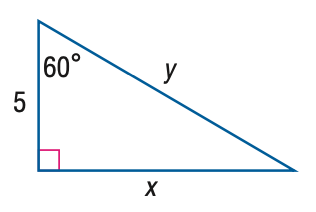Answer the mathemtical geometry problem and directly provide the correct option letter.
Question: Find y.
Choices: A: 5 B: 5 \sqrt { 2 } C: 5 \sqrt { 3 } D: 10 D 